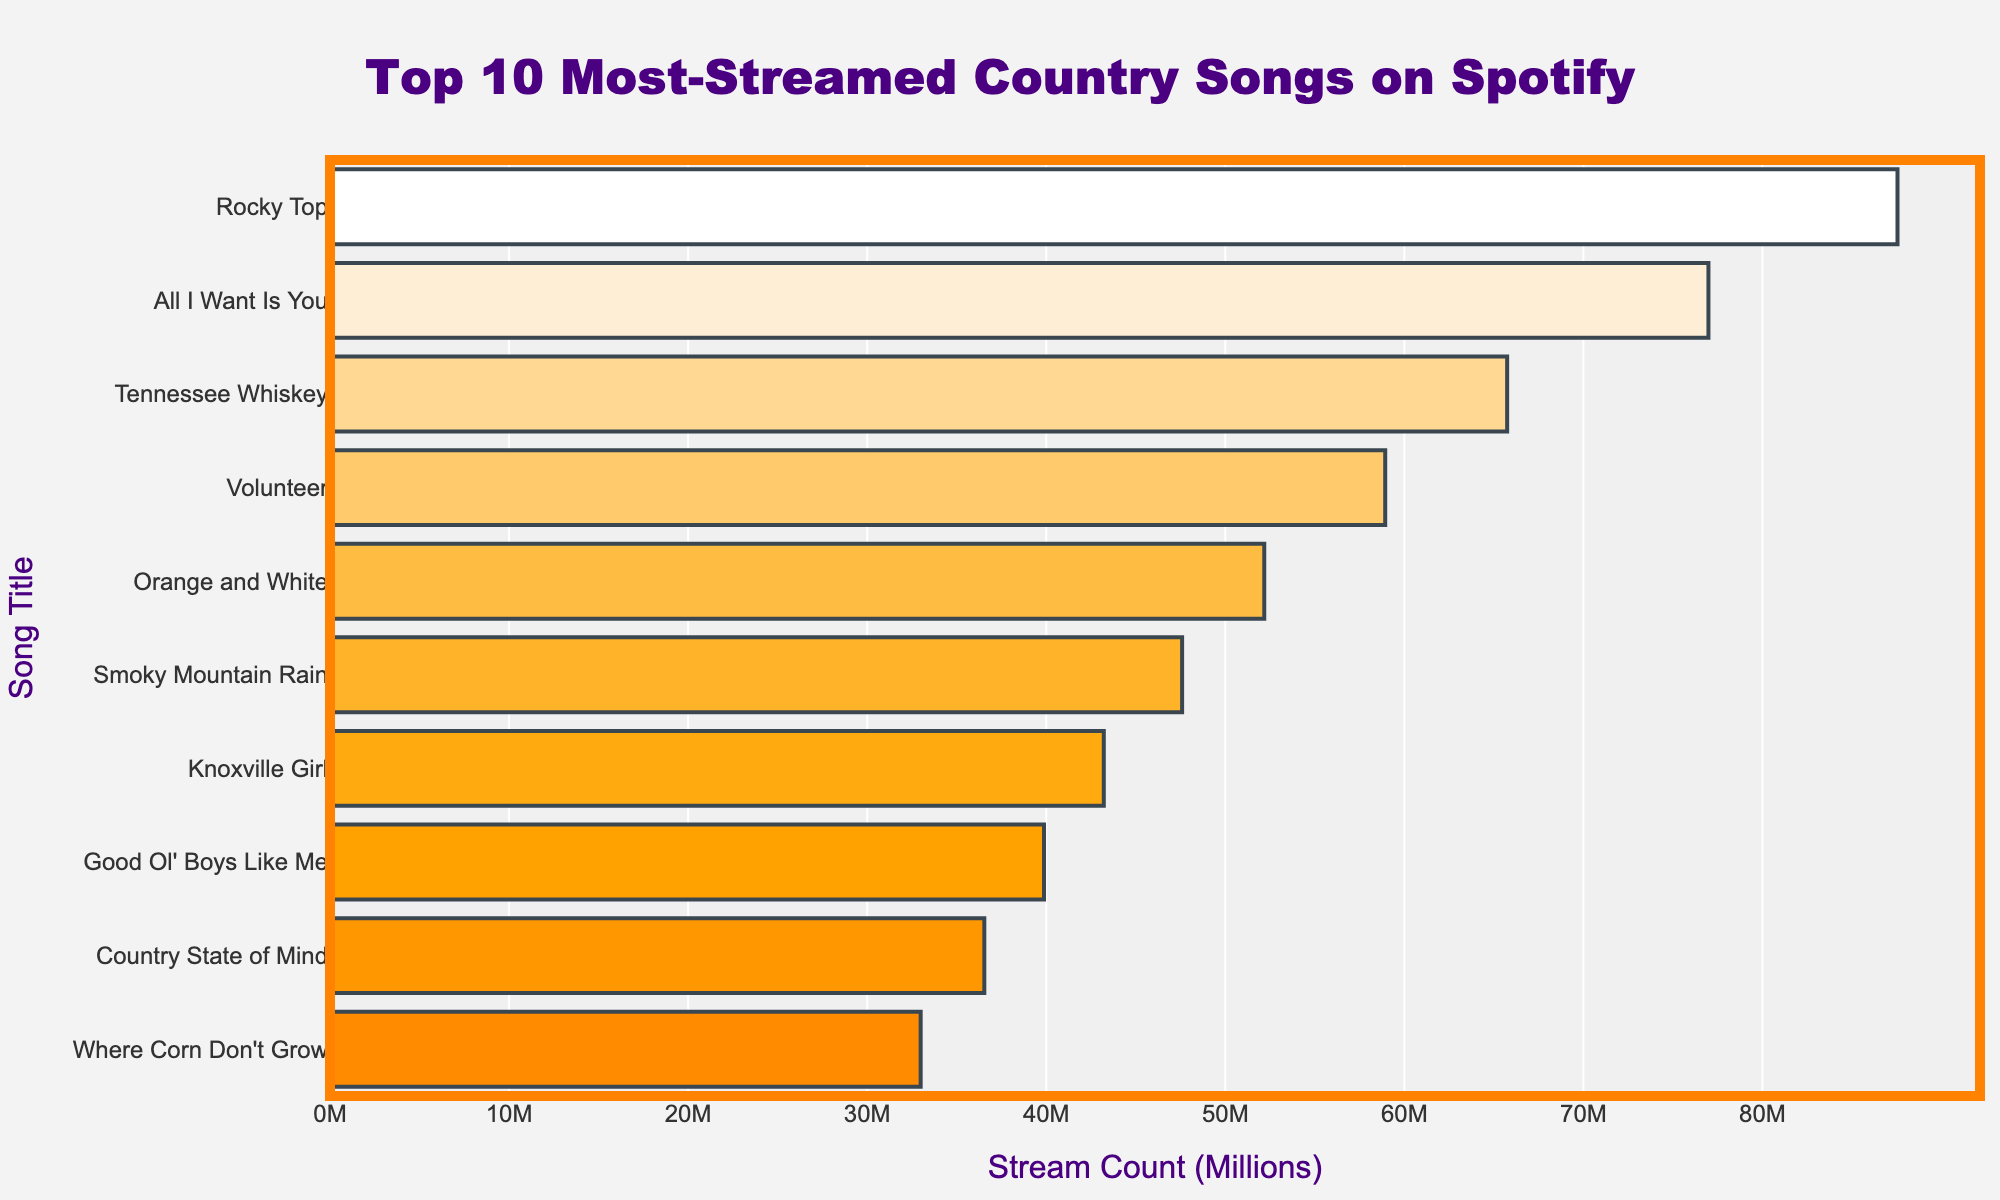Which song is the most-streamed? The song at the top of the bar chart with the highest stream count is the most-streamed.
Answer: "Rocky Top" Which artist has the highest total streams? Look for the artist associated with the song that has the highest streams. Osborne Brothers' "Rocky Top" tops the list with the highest stream count.
Answer: Osborne Brothers What is the combined stream count of the top 3 most-streamed songs? Sum the stream counts of the top 3 most-streamed songs: "Rocky Top" (87,542,301), "All I Want Is You" (76,983,254), and "Tennessee Whiskey" (65,741,982). The sum is 87,542,301 + 76,983,254 + 65,741,982 = 230,267,537.
Answer: 230,267,537 Which song has the lowest stream count? The song at the bottom of the bar chart with the lowest stream count is "Where Corn Don't Grow."
Answer: "Where Corn Don't Grow" What is the average stream count of all the listed songs? Sum the stream counts of all the songs and divide by the number of songs. Total streams are 87,542,301 + 76,983,254 + 65,741,982 + 58,932,467 + 52,176,893 + 47,589,231 + 43,215,678 + 39,876,543 + 36,542,198 + 32,987,654 = 541,588,201. The average is 541,588,201 / 10 = 54,158,820.1.
Answer: 54,158,820 How much more streamed is "Rocky Top" compared to "Tennessee Whiskey"? Subtract the stream count of "Tennessee Whiskey" from "Rocky Top." "Rocky Top" has 87,542,301 streams, and "Tennessee Whiskey" has 65,741,982 streams. The difference is 87,542,301 - 65,741,982 = 21,800,319.
Answer: 21,800,319 Which songs are streamed more than 50 million times? Identify the bars that extend beyond the 50 million mark on the x-axis. These are "Rocky Top," "All I Want Is You," "Tennessee Whiskey," "Volunteer," and "Orange and White."
Answer: 5 songs What is the stream count difference between "Volunteer" and "Smoky Mountain Rain"? Subtract the stream count of "Smoky Mountain Rain" from "Volunteer." "Volunteer" has 58,932,467 streams, and "Smoky Mountain Rain" has 47,589,231 streams. The difference is 58,932,467 - 47,589,231 = 11,343,236.
Answer: 11,343,236 Which song titles contain the name of a city or state? Look for song titles mentioning a city or state name. These are "Tennessee Whiskey," "Orange and White," "Smoky Mountain Rain," and "Knoxville Girl."
Answer: 4 songs How many songs are streamed fewer than 40 million times? Identify the bars that don't reach the 40 million mark on the x-axis. These are "Country State of Mind" and "Where Corn Don't Grow."
Answer: 2 songs 